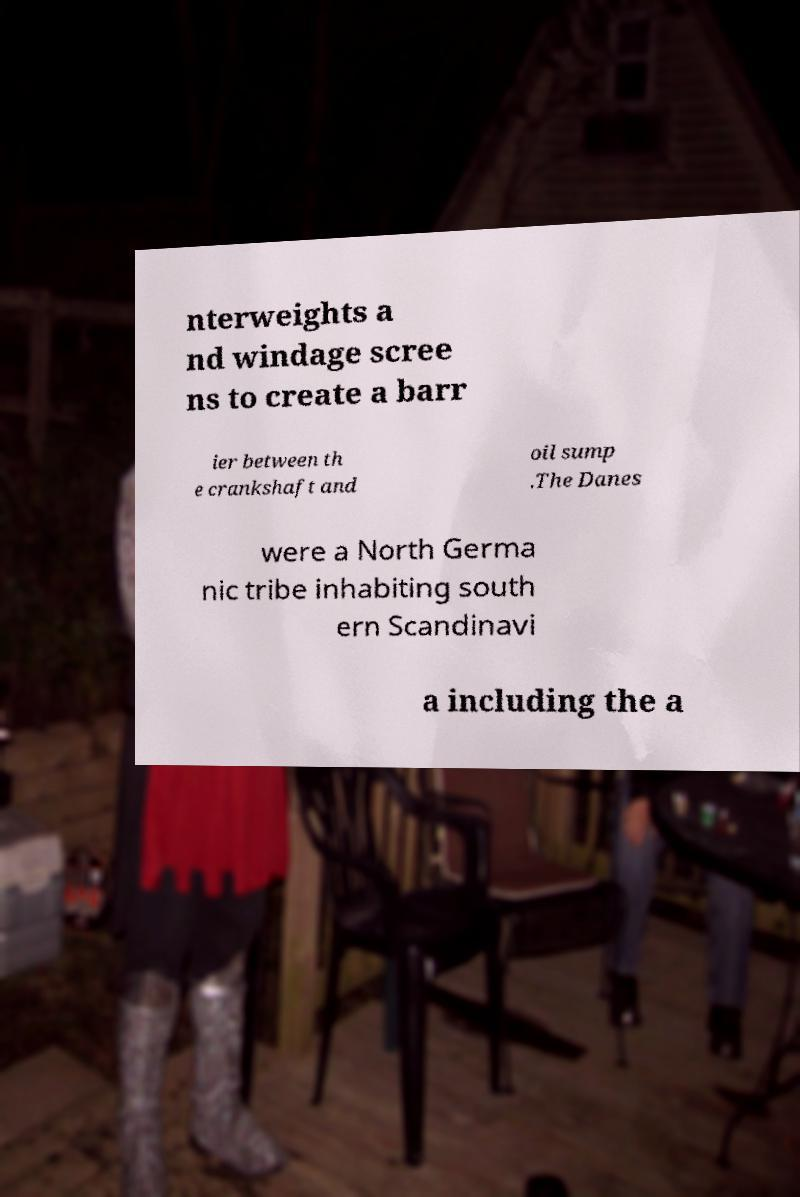I need the written content from this picture converted into text. Can you do that? nterweights a nd windage scree ns to create a barr ier between th e crankshaft and oil sump .The Danes were a North Germa nic tribe inhabiting south ern Scandinavi a including the a 